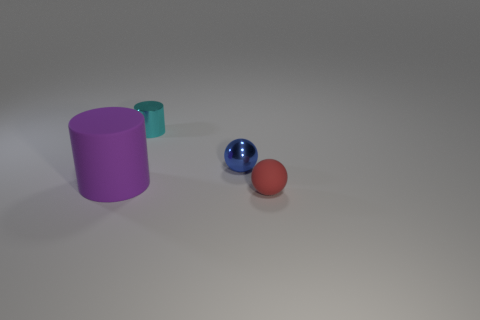Is there any other thing that is the same size as the purple rubber object?
Provide a succinct answer. No. How many blue things are objects or shiny things?
Offer a very short reply. 1. There is a metallic thing in front of the cylinder behind the large purple matte thing; what shape is it?
Your answer should be very brief. Sphere. What shape is the cyan shiny object that is the same size as the blue ball?
Make the answer very short. Cylinder. Are there any metal things that have the same color as the shiny ball?
Your response must be concise. No. Are there the same number of cyan objects behind the cyan metallic cylinder and metal spheres in front of the red thing?
Your answer should be compact. Yes. Is the shape of the cyan object the same as the tiny thing in front of the large purple matte cylinder?
Give a very brief answer. No. How many other objects are the same material as the big thing?
Your answer should be compact. 1. Are there any small cyan cylinders behind the shiny cylinder?
Provide a succinct answer. No. Is the size of the blue shiny thing the same as the rubber object that is left of the tiny blue sphere?
Your response must be concise. No. 